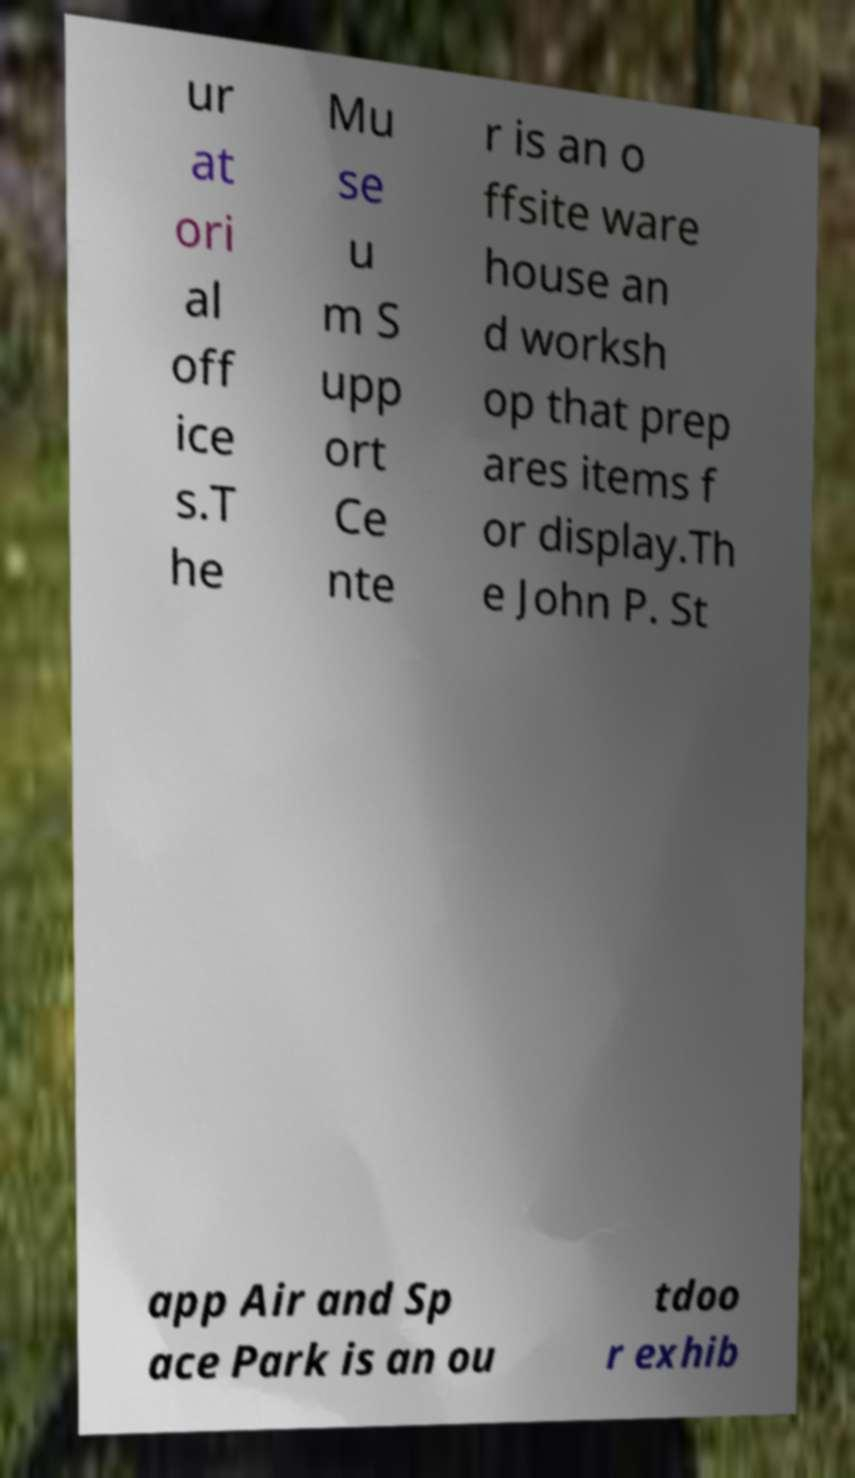Can you accurately transcribe the text from the provided image for me? ur at ori al off ice s.T he Mu se u m S upp ort Ce nte r is an o ffsite ware house an d worksh op that prep ares items f or display.Th e John P. St app Air and Sp ace Park is an ou tdoo r exhib 